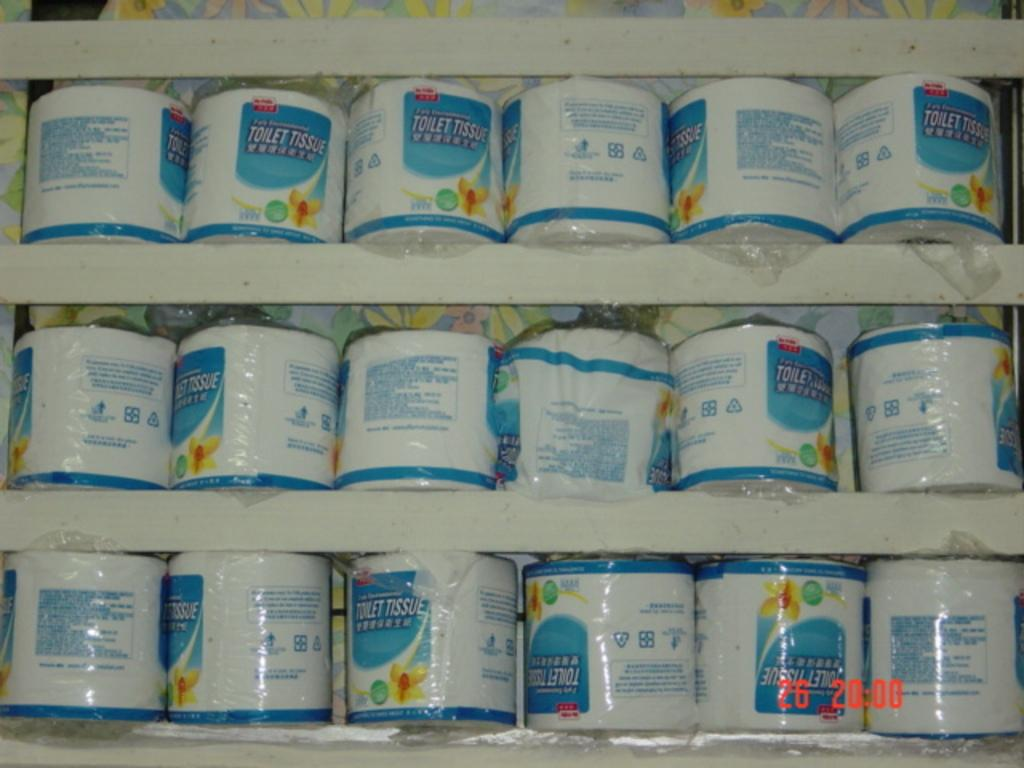<image>
Relay a brief, clear account of the picture shown. Toilet Tissue sits on display in a store 